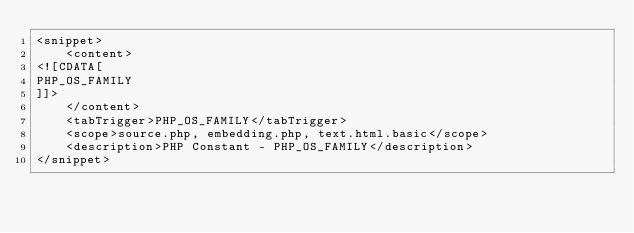Convert code to text. <code><loc_0><loc_0><loc_500><loc_500><_XML_><snippet>
	<content>
<![CDATA[
PHP_OS_FAMILY
]]>
	</content>
	<tabTrigger>PHP_OS_FAMILY</tabTrigger>
	<scope>source.php, embedding.php, text.html.basic</scope>
	<description>PHP Constant - PHP_OS_FAMILY</description>
</snippet></code> 